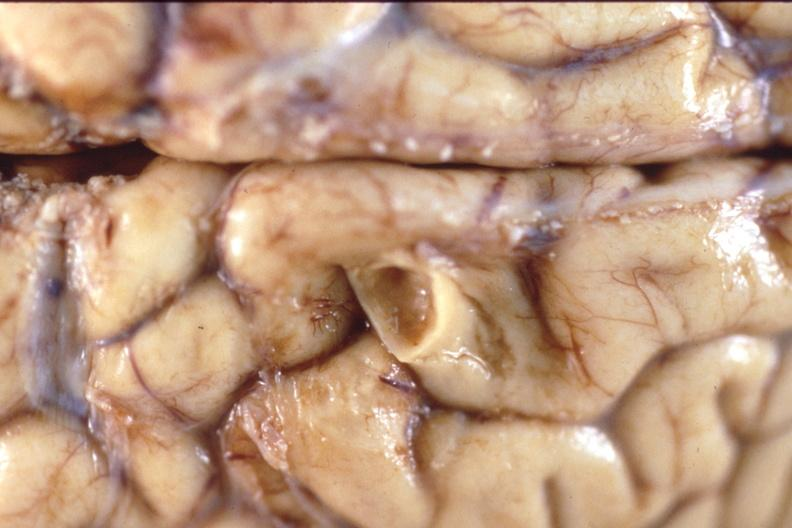s nervous present?
Answer the question using a single word or phrase. Yes 